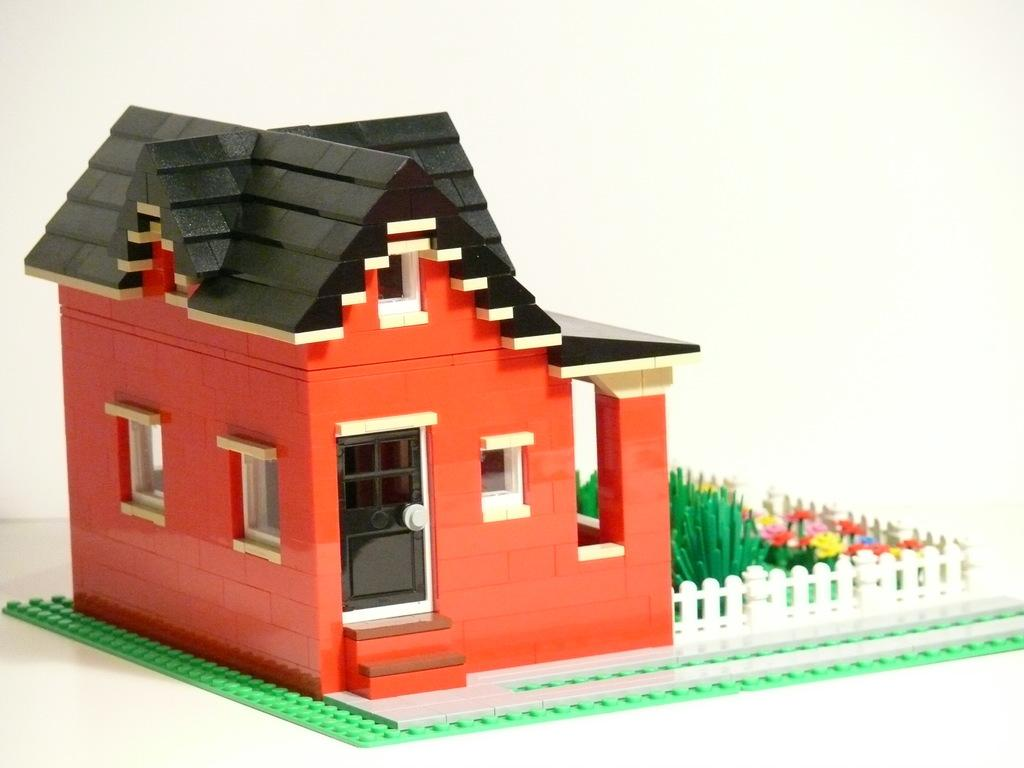What types of toys are present in the image? There are toys in the shape of a house, a fence, and plants in the image. What is the color of the background in the image? The background of the image is white in color. Can you see any clouds or oranges in the image? No, there are no clouds or oranges present in the image. Is there a plough visible in the image? No, there is no plough present in the image. 